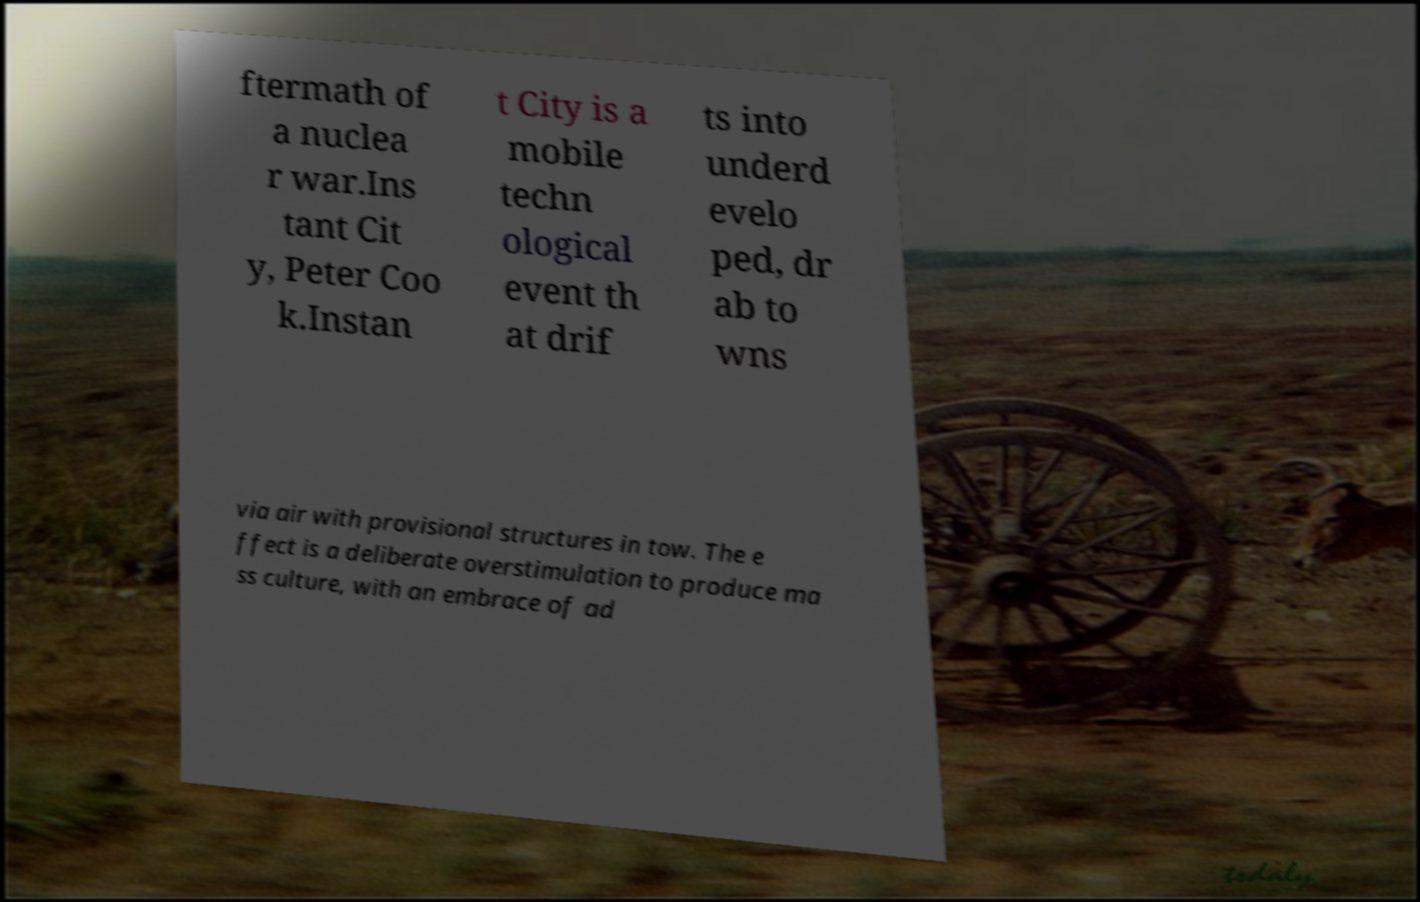Can you accurately transcribe the text from the provided image for me? ftermath of a nuclea r war.Ins tant Cit y, Peter Coo k.Instan t City is a mobile techn ological event th at drif ts into underd evelo ped, dr ab to wns via air with provisional structures in tow. The e ffect is a deliberate overstimulation to produce ma ss culture, with an embrace of ad 